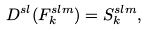Convert formula to latex. <formula><loc_0><loc_0><loc_500><loc_500>D ^ { s l } ( F _ { k } ^ { s l m } ) = S _ { k } ^ { s l m } ,</formula> 